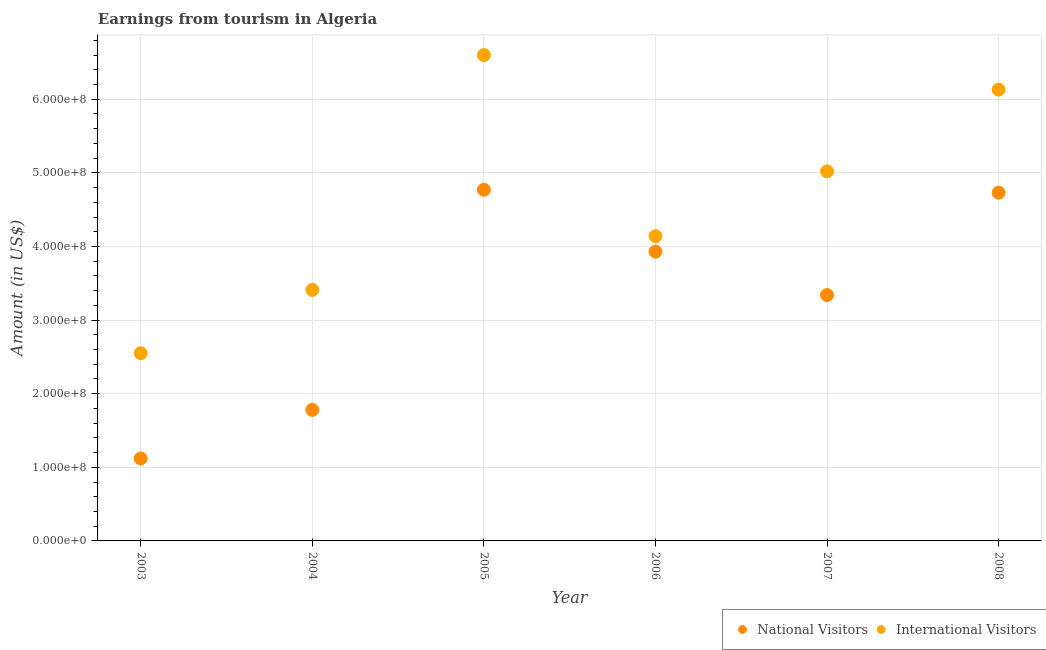How many different coloured dotlines are there?
Provide a short and direct response. 2. Is the number of dotlines equal to the number of legend labels?
Your answer should be compact. Yes. What is the amount earned from national visitors in 2003?
Ensure brevity in your answer.  1.12e+08. Across all years, what is the maximum amount earned from national visitors?
Ensure brevity in your answer.  4.77e+08. Across all years, what is the minimum amount earned from national visitors?
Give a very brief answer. 1.12e+08. In which year was the amount earned from international visitors minimum?
Your response must be concise. 2003. What is the total amount earned from national visitors in the graph?
Provide a short and direct response. 1.97e+09. What is the difference between the amount earned from international visitors in 2003 and that in 2007?
Ensure brevity in your answer.  -2.47e+08. What is the difference between the amount earned from national visitors in 2004 and the amount earned from international visitors in 2008?
Your answer should be very brief. -4.35e+08. What is the average amount earned from international visitors per year?
Provide a short and direct response. 4.64e+08. In the year 2005, what is the difference between the amount earned from international visitors and amount earned from national visitors?
Your answer should be very brief. 1.83e+08. In how many years, is the amount earned from international visitors greater than 560000000 US$?
Give a very brief answer. 2. What is the ratio of the amount earned from international visitors in 2004 to that in 2007?
Offer a terse response. 0.68. Is the amount earned from national visitors in 2003 less than that in 2005?
Your response must be concise. Yes. Is the difference between the amount earned from national visitors in 2003 and 2005 greater than the difference between the amount earned from international visitors in 2003 and 2005?
Provide a short and direct response. Yes. What is the difference between the highest and the second highest amount earned from national visitors?
Your answer should be compact. 4.00e+06. What is the difference between the highest and the lowest amount earned from international visitors?
Make the answer very short. 4.05e+08. Is the sum of the amount earned from international visitors in 2003 and 2005 greater than the maximum amount earned from national visitors across all years?
Provide a short and direct response. Yes. How many dotlines are there?
Offer a terse response. 2. How many years are there in the graph?
Offer a terse response. 6. What is the difference between two consecutive major ticks on the Y-axis?
Give a very brief answer. 1.00e+08. Are the values on the major ticks of Y-axis written in scientific E-notation?
Give a very brief answer. Yes. Does the graph contain any zero values?
Your answer should be very brief. No. Where does the legend appear in the graph?
Offer a very short reply. Bottom right. How many legend labels are there?
Make the answer very short. 2. How are the legend labels stacked?
Your response must be concise. Horizontal. What is the title of the graph?
Offer a very short reply. Earnings from tourism in Algeria. Does "Sanitation services" appear as one of the legend labels in the graph?
Ensure brevity in your answer.  No. What is the label or title of the X-axis?
Provide a succinct answer. Year. What is the label or title of the Y-axis?
Your response must be concise. Amount (in US$). What is the Amount (in US$) of National Visitors in 2003?
Provide a short and direct response. 1.12e+08. What is the Amount (in US$) of International Visitors in 2003?
Ensure brevity in your answer.  2.55e+08. What is the Amount (in US$) of National Visitors in 2004?
Provide a succinct answer. 1.78e+08. What is the Amount (in US$) in International Visitors in 2004?
Ensure brevity in your answer.  3.41e+08. What is the Amount (in US$) in National Visitors in 2005?
Keep it short and to the point. 4.77e+08. What is the Amount (in US$) of International Visitors in 2005?
Give a very brief answer. 6.60e+08. What is the Amount (in US$) of National Visitors in 2006?
Give a very brief answer. 3.93e+08. What is the Amount (in US$) in International Visitors in 2006?
Offer a very short reply. 4.14e+08. What is the Amount (in US$) in National Visitors in 2007?
Provide a short and direct response. 3.34e+08. What is the Amount (in US$) in International Visitors in 2007?
Offer a very short reply. 5.02e+08. What is the Amount (in US$) of National Visitors in 2008?
Your response must be concise. 4.73e+08. What is the Amount (in US$) of International Visitors in 2008?
Offer a terse response. 6.13e+08. Across all years, what is the maximum Amount (in US$) of National Visitors?
Your response must be concise. 4.77e+08. Across all years, what is the maximum Amount (in US$) in International Visitors?
Offer a very short reply. 6.60e+08. Across all years, what is the minimum Amount (in US$) in National Visitors?
Make the answer very short. 1.12e+08. Across all years, what is the minimum Amount (in US$) in International Visitors?
Your answer should be compact. 2.55e+08. What is the total Amount (in US$) in National Visitors in the graph?
Make the answer very short. 1.97e+09. What is the total Amount (in US$) of International Visitors in the graph?
Make the answer very short. 2.78e+09. What is the difference between the Amount (in US$) in National Visitors in 2003 and that in 2004?
Your answer should be very brief. -6.60e+07. What is the difference between the Amount (in US$) in International Visitors in 2003 and that in 2004?
Your response must be concise. -8.60e+07. What is the difference between the Amount (in US$) of National Visitors in 2003 and that in 2005?
Your response must be concise. -3.65e+08. What is the difference between the Amount (in US$) of International Visitors in 2003 and that in 2005?
Provide a succinct answer. -4.05e+08. What is the difference between the Amount (in US$) in National Visitors in 2003 and that in 2006?
Your answer should be compact. -2.81e+08. What is the difference between the Amount (in US$) of International Visitors in 2003 and that in 2006?
Offer a terse response. -1.59e+08. What is the difference between the Amount (in US$) in National Visitors in 2003 and that in 2007?
Make the answer very short. -2.22e+08. What is the difference between the Amount (in US$) in International Visitors in 2003 and that in 2007?
Make the answer very short. -2.47e+08. What is the difference between the Amount (in US$) of National Visitors in 2003 and that in 2008?
Provide a succinct answer. -3.61e+08. What is the difference between the Amount (in US$) of International Visitors in 2003 and that in 2008?
Make the answer very short. -3.58e+08. What is the difference between the Amount (in US$) in National Visitors in 2004 and that in 2005?
Ensure brevity in your answer.  -2.99e+08. What is the difference between the Amount (in US$) in International Visitors in 2004 and that in 2005?
Give a very brief answer. -3.19e+08. What is the difference between the Amount (in US$) of National Visitors in 2004 and that in 2006?
Your answer should be very brief. -2.15e+08. What is the difference between the Amount (in US$) in International Visitors in 2004 and that in 2006?
Ensure brevity in your answer.  -7.30e+07. What is the difference between the Amount (in US$) of National Visitors in 2004 and that in 2007?
Your response must be concise. -1.56e+08. What is the difference between the Amount (in US$) in International Visitors in 2004 and that in 2007?
Your response must be concise. -1.61e+08. What is the difference between the Amount (in US$) in National Visitors in 2004 and that in 2008?
Offer a very short reply. -2.95e+08. What is the difference between the Amount (in US$) of International Visitors in 2004 and that in 2008?
Your answer should be compact. -2.72e+08. What is the difference between the Amount (in US$) in National Visitors in 2005 and that in 2006?
Keep it short and to the point. 8.40e+07. What is the difference between the Amount (in US$) in International Visitors in 2005 and that in 2006?
Provide a succinct answer. 2.46e+08. What is the difference between the Amount (in US$) of National Visitors in 2005 and that in 2007?
Your answer should be very brief. 1.43e+08. What is the difference between the Amount (in US$) in International Visitors in 2005 and that in 2007?
Your answer should be very brief. 1.58e+08. What is the difference between the Amount (in US$) in International Visitors in 2005 and that in 2008?
Your answer should be very brief. 4.70e+07. What is the difference between the Amount (in US$) of National Visitors in 2006 and that in 2007?
Offer a terse response. 5.90e+07. What is the difference between the Amount (in US$) of International Visitors in 2006 and that in 2007?
Offer a terse response. -8.80e+07. What is the difference between the Amount (in US$) in National Visitors in 2006 and that in 2008?
Keep it short and to the point. -8.00e+07. What is the difference between the Amount (in US$) in International Visitors in 2006 and that in 2008?
Your response must be concise. -1.99e+08. What is the difference between the Amount (in US$) in National Visitors in 2007 and that in 2008?
Keep it short and to the point. -1.39e+08. What is the difference between the Amount (in US$) of International Visitors in 2007 and that in 2008?
Provide a short and direct response. -1.11e+08. What is the difference between the Amount (in US$) of National Visitors in 2003 and the Amount (in US$) of International Visitors in 2004?
Offer a very short reply. -2.29e+08. What is the difference between the Amount (in US$) in National Visitors in 2003 and the Amount (in US$) in International Visitors in 2005?
Give a very brief answer. -5.48e+08. What is the difference between the Amount (in US$) in National Visitors in 2003 and the Amount (in US$) in International Visitors in 2006?
Your answer should be very brief. -3.02e+08. What is the difference between the Amount (in US$) in National Visitors in 2003 and the Amount (in US$) in International Visitors in 2007?
Provide a short and direct response. -3.90e+08. What is the difference between the Amount (in US$) in National Visitors in 2003 and the Amount (in US$) in International Visitors in 2008?
Offer a terse response. -5.01e+08. What is the difference between the Amount (in US$) in National Visitors in 2004 and the Amount (in US$) in International Visitors in 2005?
Provide a succinct answer. -4.82e+08. What is the difference between the Amount (in US$) in National Visitors in 2004 and the Amount (in US$) in International Visitors in 2006?
Give a very brief answer. -2.36e+08. What is the difference between the Amount (in US$) in National Visitors in 2004 and the Amount (in US$) in International Visitors in 2007?
Offer a very short reply. -3.24e+08. What is the difference between the Amount (in US$) in National Visitors in 2004 and the Amount (in US$) in International Visitors in 2008?
Keep it short and to the point. -4.35e+08. What is the difference between the Amount (in US$) in National Visitors in 2005 and the Amount (in US$) in International Visitors in 2006?
Your answer should be compact. 6.30e+07. What is the difference between the Amount (in US$) in National Visitors in 2005 and the Amount (in US$) in International Visitors in 2007?
Your answer should be very brief. -2.50e+07. What is the difference between the Amount (in US$) in National Visitors in 2005 and the Amount (in US$) in International Visitors in 2008?
Give a very brief answer. -1.36e+08. What is the difference between the Amount (in US$) of National Visitors in 2006 and the Amount (in US$) of International Visitors in 2007?
Offer a terse response. -1.09e+08. What is the difference between the Amount (in US$) in National Visitors in 2006 and the Amount (in US$) in International Visitors in 2008?
Ensure brevity in your answer.  -2.20e+08. What is the difference between the Amount (in US$) of National Visitors in 2007 and the Amount (in US$) of International Visitors in 2008?
Provide a succinct answer. -2.79e+08. What is the average Amount (in US$) of National Visitors per year?
Offer a very short reply. 3.28e+08. What is the average Amount (in US$) in International Visitors per year?
Your answer should be very brief. 4.64e+08. In the year 2003, what is the difference between the Amount (in US$) in National Visitors and Amount (in US$) in International Visitors?
Provide a short and direct response. -1.43e+08. In the year 2004, what is the difference between the Amount (in US$) in National Visitors and Amount (in US$) in International Visitors?
Make the answer very short. -1.63e+08. In the year 2005, what is the difference between the Amount (in US$) of National Visitors and Amount (in US$) of International Visitors?
Keep it short and to the point. -1.83e+08. In the year 2006, what is the difference between the Amount (in US$) in National Visitors and Amount (in US$) in International Visitors?
Provide a succinct answer. -2.10e+07. In the year 2007, what is the difference between the Amount (in US$) of National Visitors and Amount (in US$) of International Visitors?
Offer a terse response. -1.68e+08. In the year 2008, what is the difference between the Amount (in US$) of National Visitors and Amount (in US$) of International Visitors?
Ensure brevity in your answer.  -1.40e+08. What is the ratio of the Amount (in US$) of National Visitors in 2003 to that in 2004?
Your answer should be compact. 0.63. What is the ratio of the Amount (in US$) in International Visitors in 2003 to that in 2004?
Offer a terse response. 0.75. What is the ratio of the Amount (in US$) of National Visitors in 2003 to that in 2005?
Your response must be concise. 0.23. What is the ratio of the Amount (in US$) of International Visitors in 2003 to that in 2005?
Your response must be concise. 0.39. What is the ratio of the Amount (in US$) of National Visitors in 2003 to that in 2006?
Offer a very short reply. 0.28. What is the ratio of the Amount (in US$) of International Visitors in 2003 to that in 2006?
Ensure brevity in your answer.  0.62. What is the ratio of the Amount (in US$) of National Visitors in 2003 to that in 2007?
Provide a short and direct response. 0.34. What is the ratio of the Amount (in US$) in International Visitors in 2003 to that in 2007?
Your answer should be compact. 0.51. What is the ratio of the Amount (in US$) in National Visitors in 2003 to that in 2008?
Keep it short and to the point. 0.24. What is the ratio of the Amount (in US$) in International Visitors in 2003 to that in 2008?
Your response must be concise. 0.42. What is the ratio of the Amount (in US$) of National Visitors in 2004 to that in 2005?
Provide a short and direct response. 0.37. What is the ratio of the Amount (in US$) of International Visitors in 2004 to that in 2005?
Offer a very short reply. 0.52. What is the ratio of the Amount (in US$) in National Visitors in 2004 to that in 2006?
Offer a terse response. 0.45. What is the ratio of the Amount (in US$) in International Visitors in 2004 to that in 2006?
Your answer should be very brief. 0.82. What is the ratio of the Amount (in US$) of National Visitors in 2004 to that in 2007?
Make the answer very short. 0.53. What is the ratio of the Amount (in US$) in International Visitors in 2004 to that in 2007?
Offer a terse response. 0.68. What is the ratio of the Amount (in US$) in National Visitors in 2004 to that in 2008?
Provide a succinct answer. 0.38. What is the ratio of the Amount (in US$) in International Visitors in 2004 to that in 2008?
Offer a very short reply. 0.56. What is the ratio of the Amount (in US$) in National Visitors in 2005 to that in 2006?
Ensure brevity in your answer.  1.21. What is the ratio of the Amount (in US$) in International Visitors in 2005 to that in 2006?
Provide a short and direct response. 1.59. What is the ratio of the Amount (in US$) in National Visitors in 2005 to that in 2007?
Your answer should be very brief. 1.43. What is the ratio of the Amount (in US$) in International Visitors in 2005 to that in 2007?
Provide a short and direct response. 1.31. What is the ratio of the Amount (in US$) of National Visitors in 2005 to that in 2008?
Offer a terse response. 1.01. What is the ratio of the Amount (in US$) of International Visitors in 2005 to that in 2008?
Make the answer very short. 1.08. What is the ratio of the Amount (in US$) of National Visitors in 2006 to that in 2007?
Offer a terse response. 1.18. What is the ratio of the Amount (in US$) in International Visitors in 2006 to that in 2007?
Your response must be concise. 0.82. What is the ratio of the Amount (in US$) of National Visitors in 2006 to that in 2008?
Offer a very short reply. 0.83. What is the ratio of the Amount (in US$) of International Visitors in 2006 to that in 2008?
Provide a short and direct response. 0.68. What is the ratio of the Amount (in US$) in National Visitors in 2007 to that in 2008?
Make the answer very short. 0.71. What is the ratio of the Amount (in US$) in International Visitors in 2007 to that in 2008?
Provide a succinct answer. 0.82. What is the difference between the highest and the second highest Amount (in US$) in National Visitors?
Offer a very short reply. 4.00e+06. What is the difference between the highest and the second highest Amount (in US$) of International Visitors?
Make the answer very short. 4.70e+07. What is the difference between the highest and the lowest Amount (in US$) of National Visitors?
Ensure brevity in your answer.  3.65e+08. What is the difference between the highest and the lowest Amount (in US$) in International Visitors?
Give a very brief answer. 4.05e+08. 